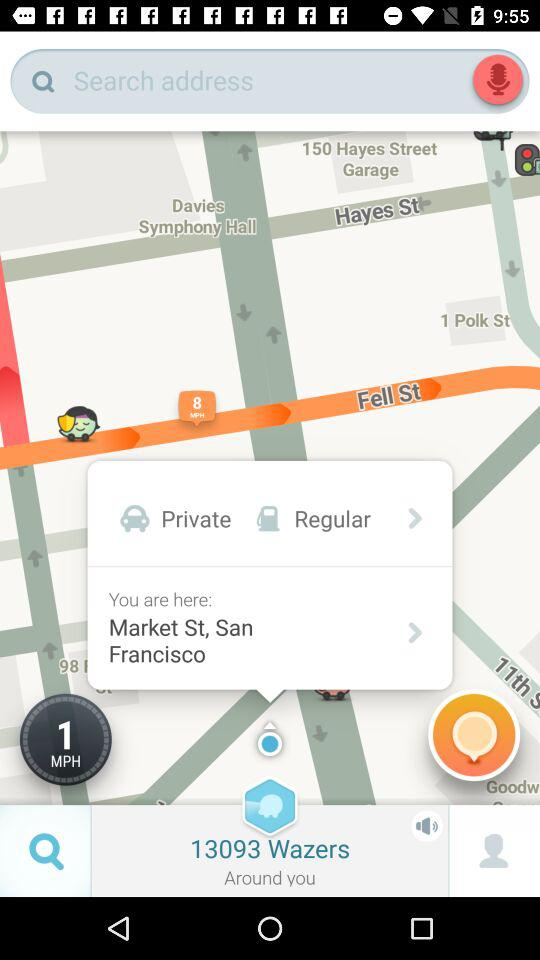What is the present location? The location is Market Street in San Francisco. 